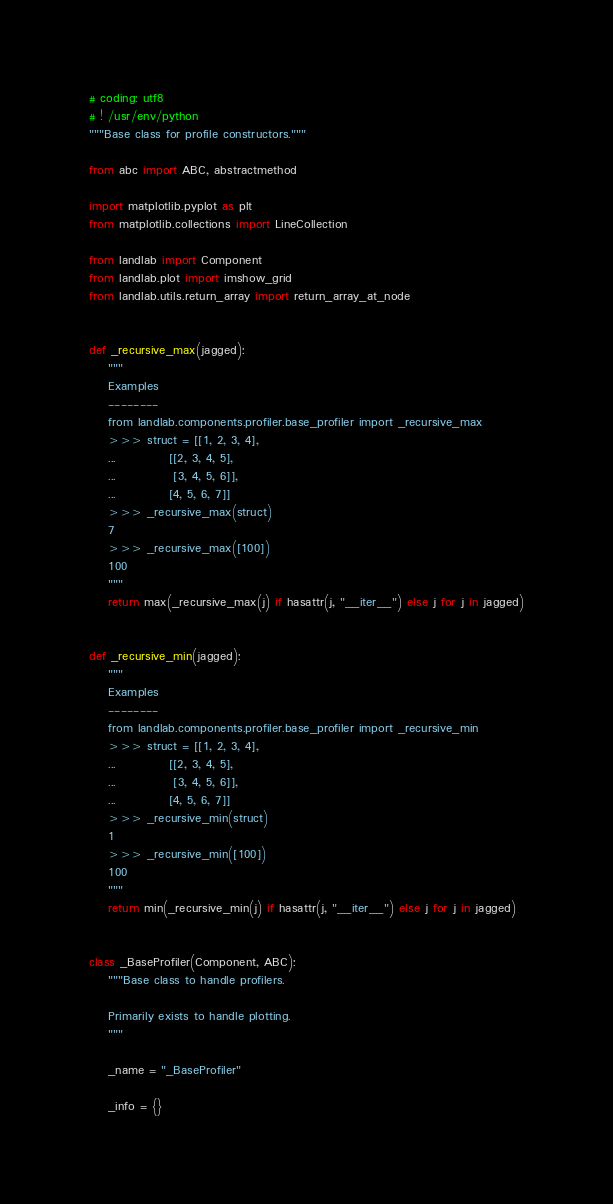Convert code to text. <code><loc_0><loc_0><loc_500><loc_500><_Python_># coding: utf8
# ! /usr/env/python
"""Base class for profile constructors."""

from abc import ABC, abstractmethod

import matplotlib.pyplot as plt
from matplotlib.collections import LineCollection

from landlab import Component
from landlab.plot import imshow_grid
from landlab.utils.return_array import return_array_at_node


def _recursive_max(jagged):
    """
    Examples
    --------
    from landlab.components.profiler.base_profiler import _recursive_max
    >>> struct = [[1, 2, 3, 4],
    ...           [[2, 3, 4, 5],
    ...            [3, 4, 5, 6]],
    ...           [4, 5, 6, 7]]
    >>> _recursive_max(struct)
    7
    >>> _recursive_max([100])
    100
    """
    return max(_recursive_max(j) if hasattr(j, "__iter__") else j for j in jagged)


def _recursive_min(jagged):
    """
    Examples
    --------
    from landlab.components.profiler.base_profiler import _recursive_min
    >>> struct = [[1, 2, 3, 4],
    ...           [[2, 3, 4, 5],
    ...            [3, 4, 5, 6]],
    ...           [4, 5, 6, 7]]
    >>> _recursive_min(struct)
    1
    >>> _recursive_min([100])
    100
    """
    return min(_recursive_min(j) if hasattr(j, "__iter__") else j for j in jagged)


class _BaseProfiler(Component, ABC):
    """Base class to handle profilers.

    Primarily exists to handle plotting.
    """

    _name = "_BaseProfiler"

    _info = {}
</code> 